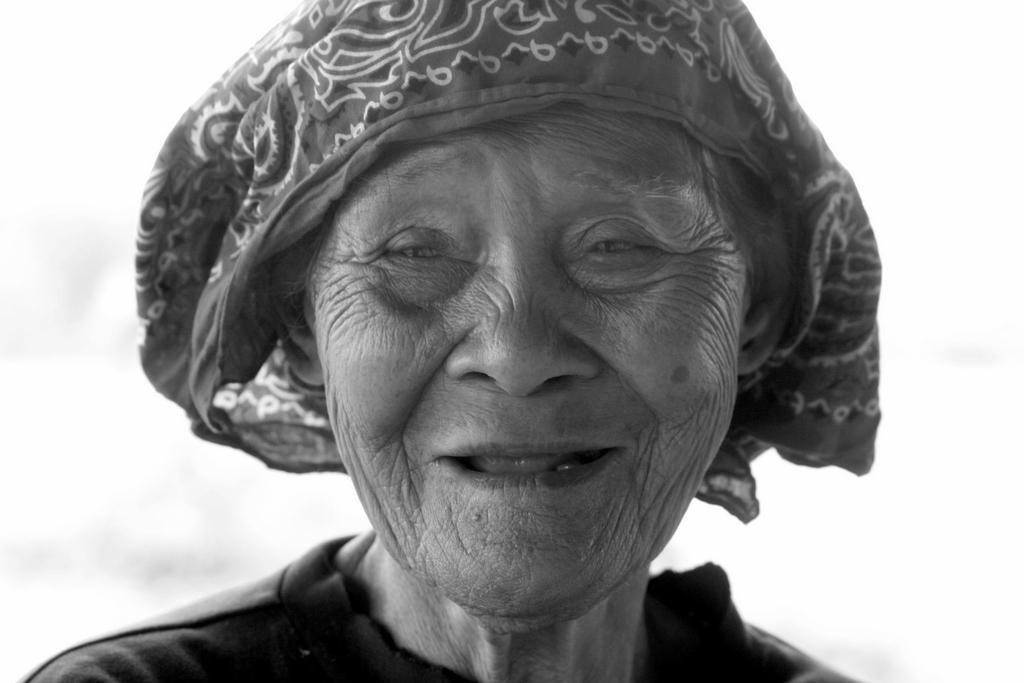Can you describe this image briefly? In this image we can see an old lady. A lady is smiling at the image. 